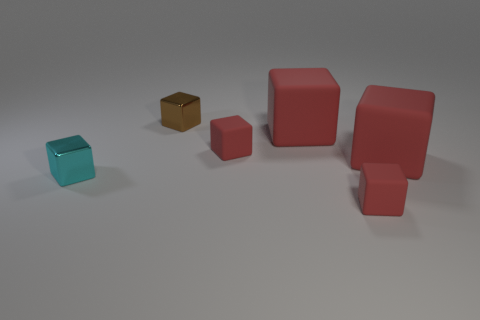Subtract all red blocks. How many were subtracted if there are2red blocks left? 2 Add 4 big purple matte objects. How many objects exist? 10 Subtract all small matte blocks. How many blocks are left? 4 Subtract 6 cubes. How many cubes are left? 0 Subtract all brown cubes. How many cubes are left? 5 Subtract all yellow balls. How many red cubes are left? 4 Add 2 big red things. How many big red things are left? 4 Add 4 yellow rubber cylinders. How many yellow rubber cylinders exist? 4 Subtract 0 gray balls. How many objects are left? 6 Subtract all yellow blocks. Subtract all green cylinders. How many blocks are left? 6 